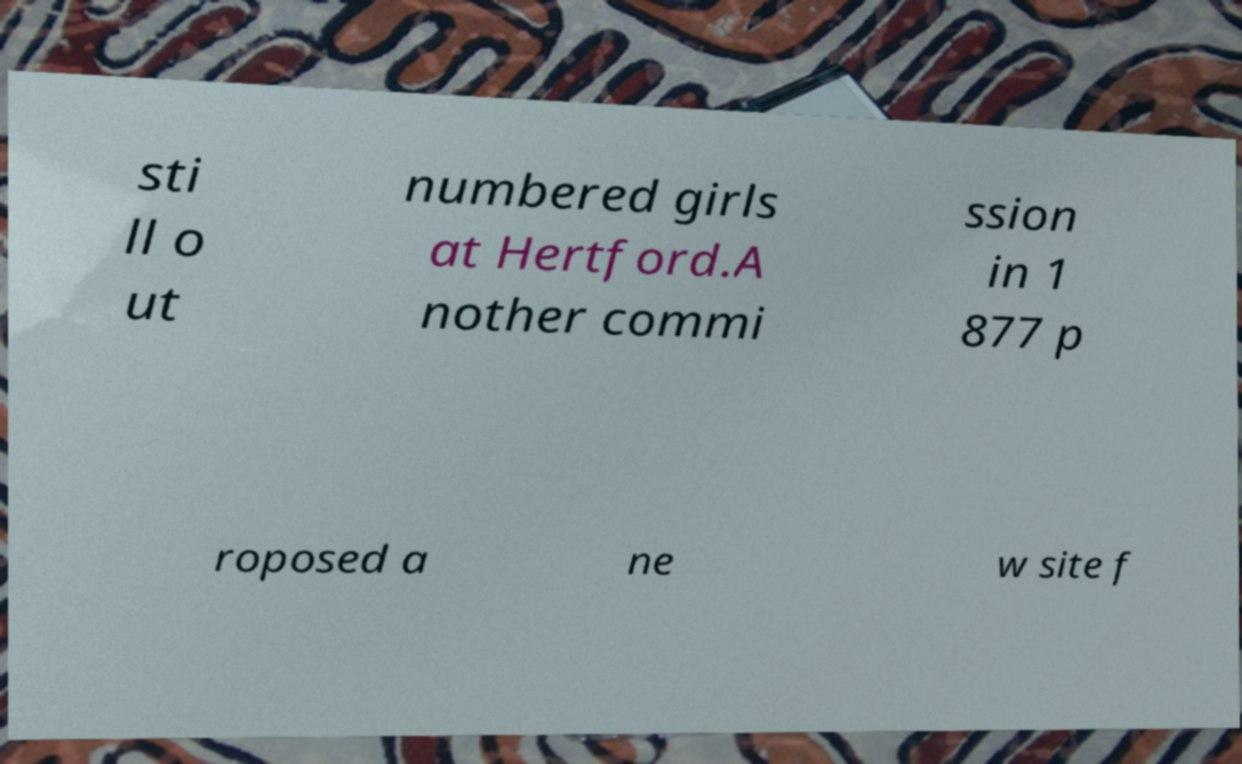Can you read and provide the text displayed in the image?This photo seems to have some interesting text. Can you extract and type it out for me? sti ll o ut numbered girls at Hertford.A nother commi ssion in 1 877 p roposed a ne w site f 